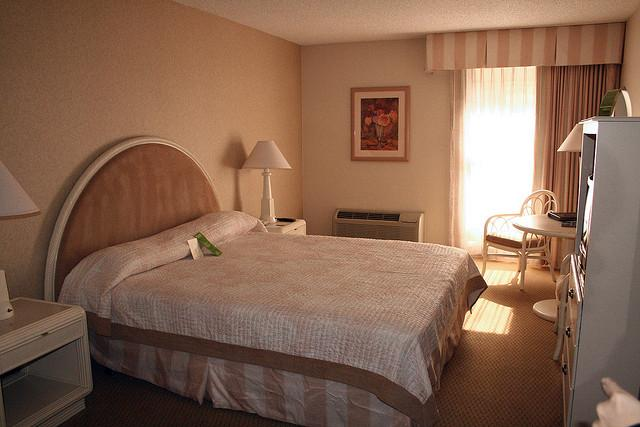What type of establishment is known to put notecards on beds like this? Please explain your reasoning. hotels. The room has the layout and interior features consistent with answer a in addition to the practice of leaving notecards which is common for this type of establishment. 